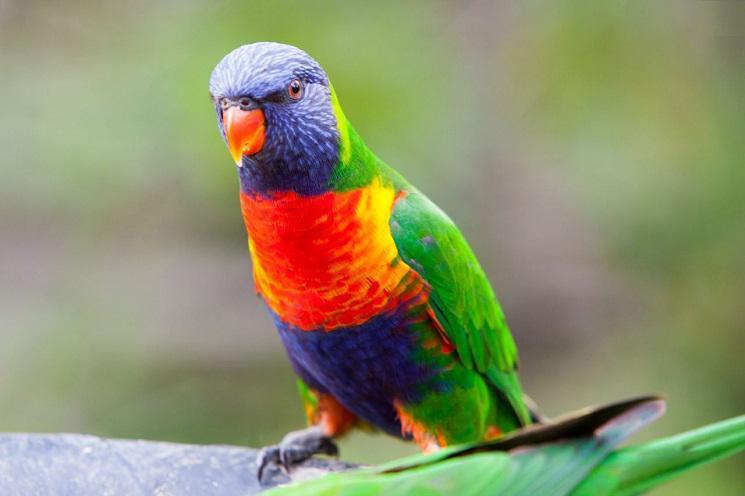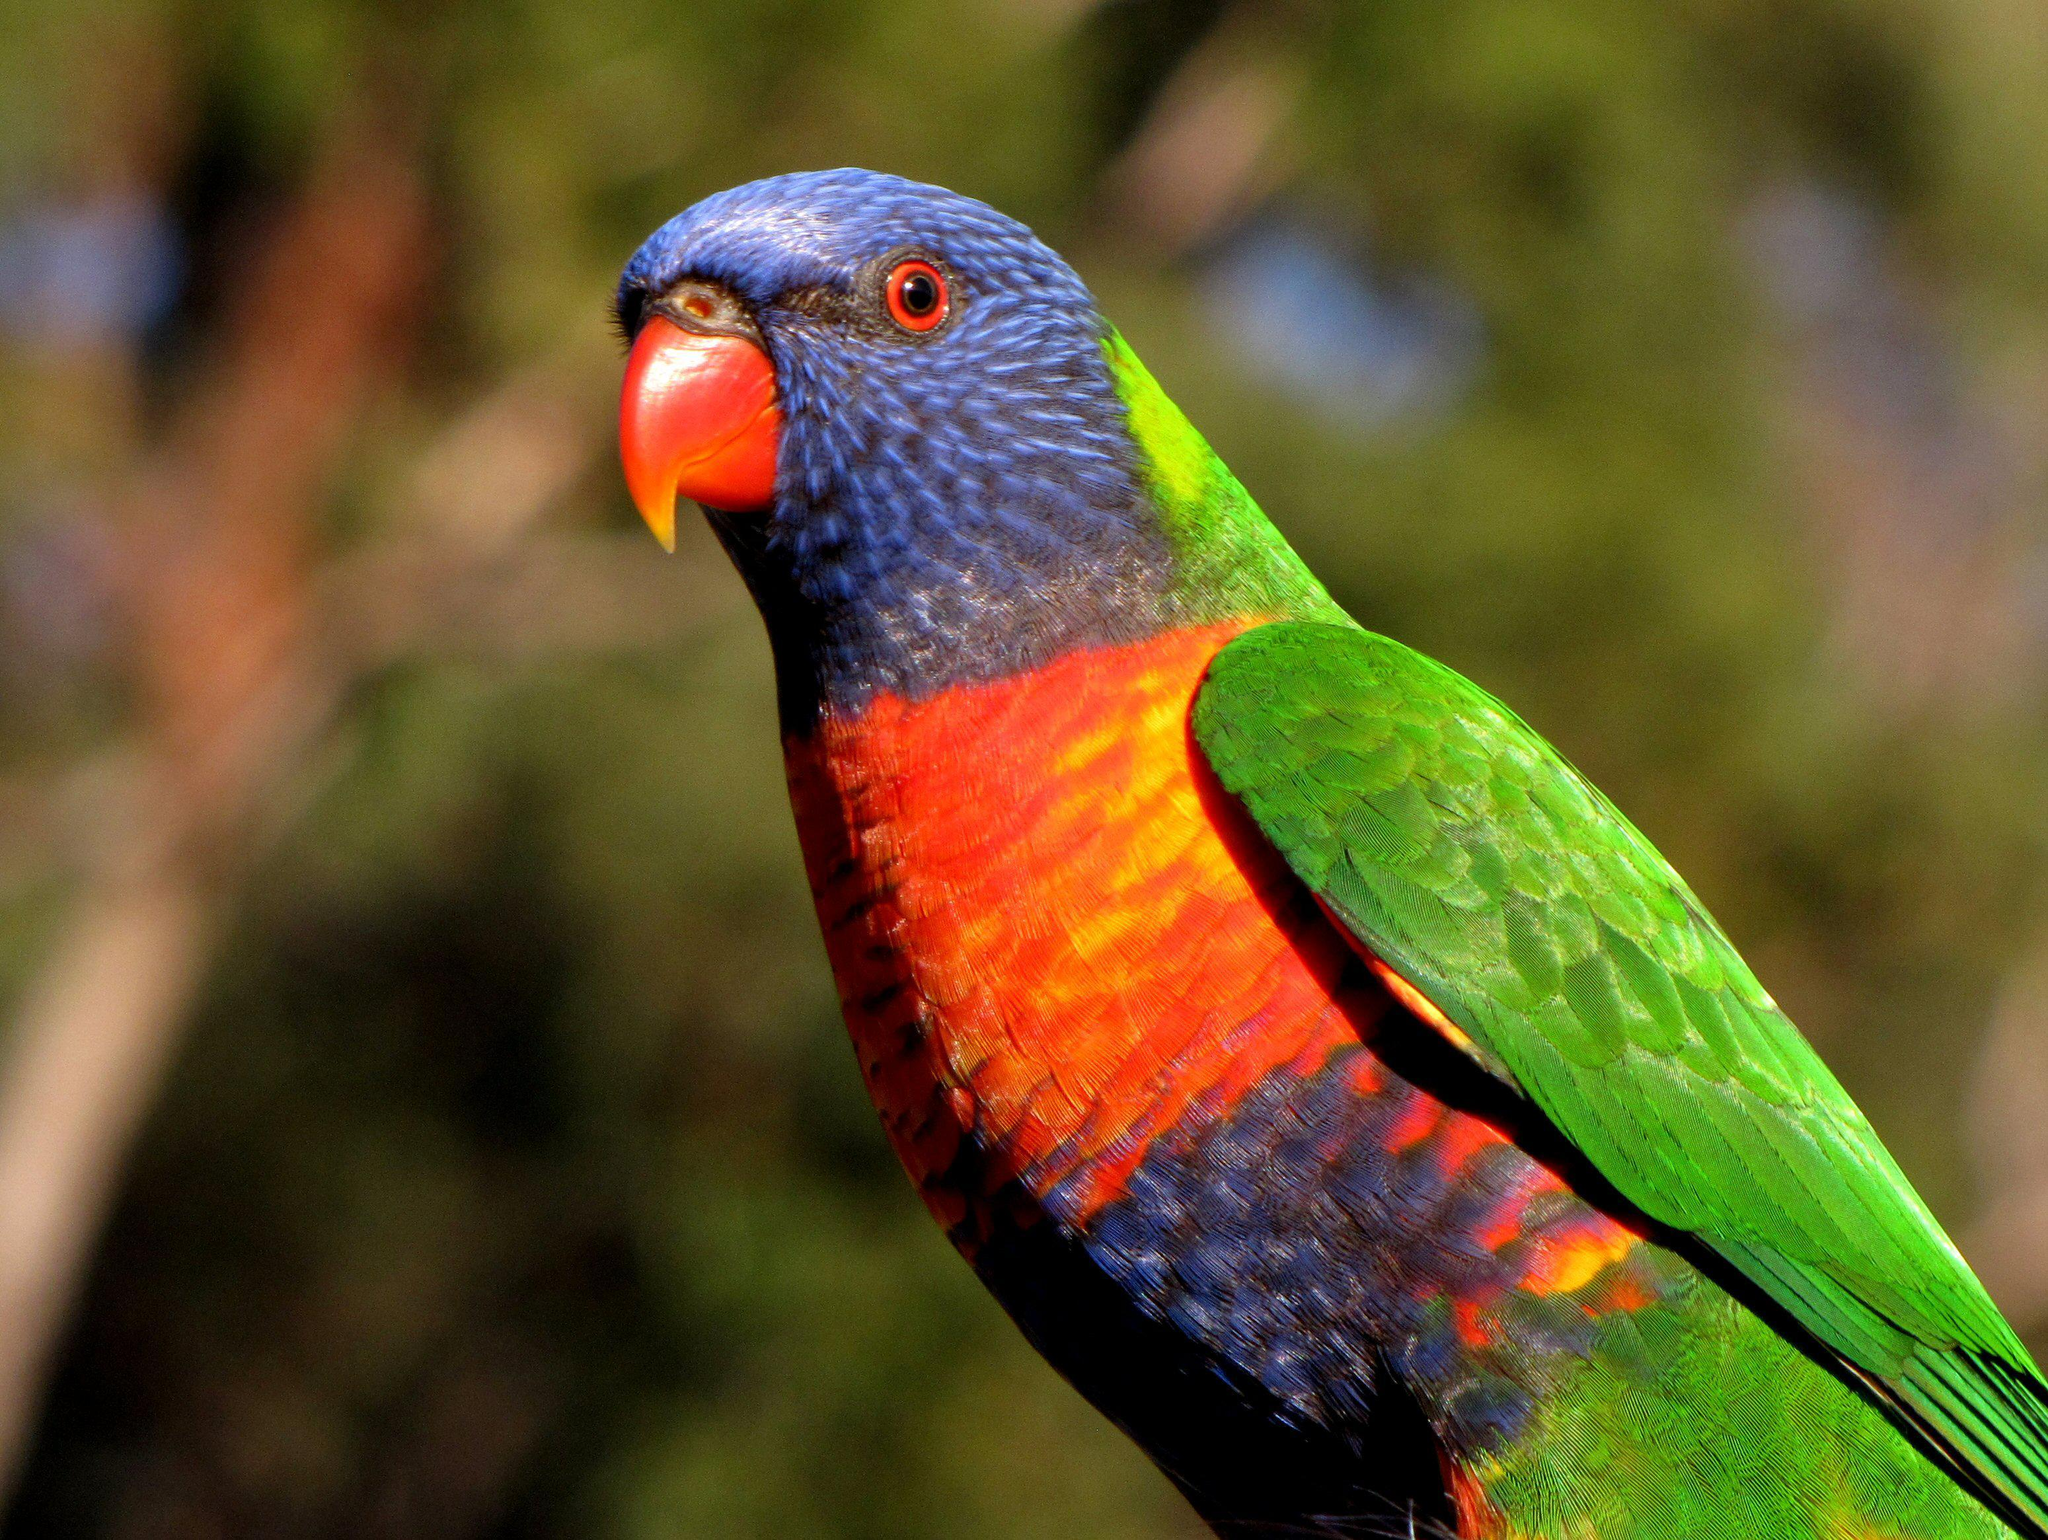The first image is the image on the left, the second image is the image on the right. Examine the images to the left and right. Is the description "All birds are alone." accurate? Answer yes or no. Yes. 